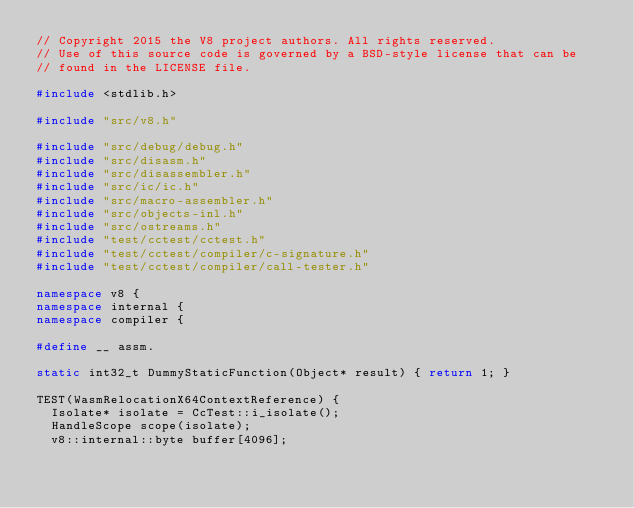<code> <loc_0><loc_0><loc_500><loc_500><_C++_>// Copyright 2015 the V8 project authors. All rights reserved.
// Use of this source code is governed by a BSD-style license that can be
// found in the LICENSE file.

#include <stdlib.h>

#include "src/v8.h"

#include "src/debug/debug.h"
#include "src/disasm.h"
#include "src/disassembler.h"
#include "src/ic/ic.h"
#include "src/macro-assembler.h"
#include "src/objects-inl.h"
#include "src/ostreams.h"
#include "test/cctest/cctest.h"
#include "test/cctest/compiler/c-signature.h"
#include "test/cctest/compiler/call-tester.h"

namespace v8 {
namespace internal {
namespace compiler {

#define __ assm.

static int32_t DummyStaticFunction(Object* result) { return 1; }

TEST(WasmRelocationX64ContextReference) {
  Isolate* isolate = CcTest::i_isolate();
  HandleScope scope(isolate);
  v8::internal::byte buffer[4096];</code> 